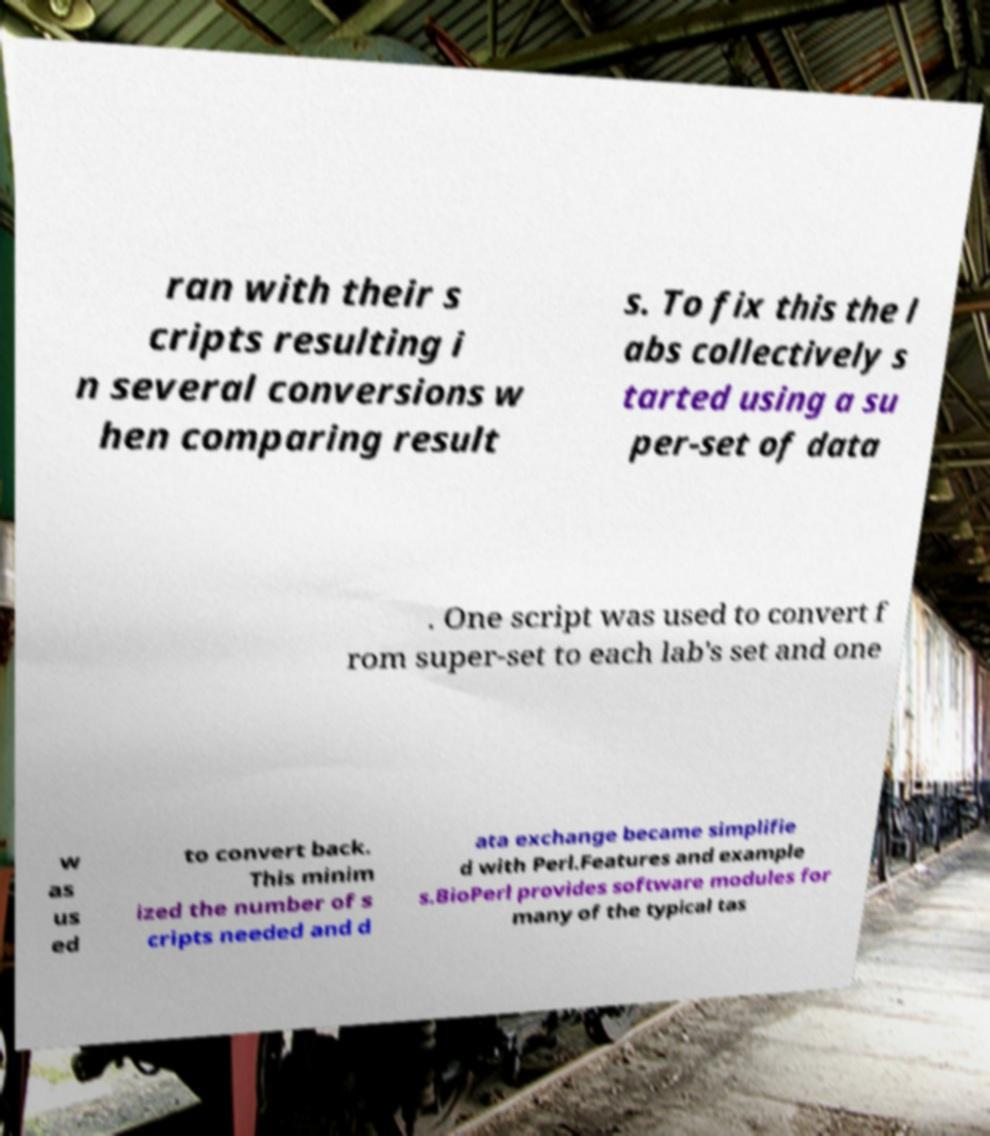Can you read and provide the text displayed in the image?This photo seems to have some interesting text. Can you extract and type it out for me? ran with their s cripts resulting i n several conversions w hen comparing result s. To fix this the l abs collectively s tarted using a su per-set of data . One script was used to convert f rom super-set to each lab's set and one w as us ed to convert back. This minim ized the number of s cripts needed and d ata exchange became simplifie d with Perl.Features and example s.BioPerl provides software modules for many of the typical tas 